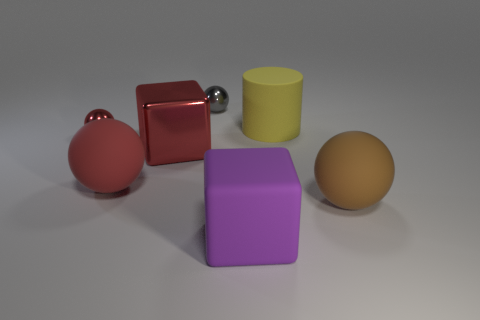Add 3 gray matte cubes. How many objects exist? 10 Subtract all balls. How many objects are left? 3 Subtract 2 red balls. How many objects are left? 5 Subtract all small gray objects. Subtract all red balls. How many objects are left? 4 Add 5 yellow matte cylinders. How many yellow matte cylinders are left? 6 Add 6 small things. How many small things exist? 8 